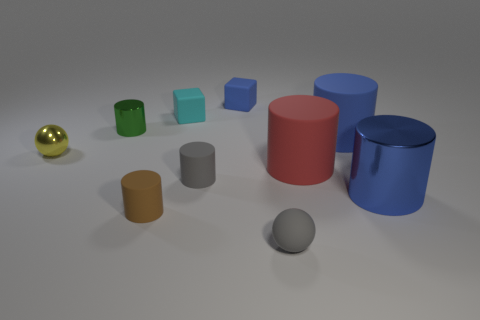Is the tiny yellow thing made of the same material as the big object that is in front of the big red cylinder?
Give a very brief answer. Yes. There is a blue cylinder behind the yellow thing; what is it made of?
Ensure brevity in your answer.  Rubber. What is the size of the yellow ball?
Provide a succinct answer. Small. There is a blue rubber object that is in front of the blue matte cube; is its size the same as the cube that is in front of the blue rubber cube?
Your answer should be compact. No. There is a blue metallic object that is the same shape as the large blue rubber object; what is its size?
Offer a very short reply. Large. There is a green thing; does it have the same size as the metallic cylinder in front of the green cylinder?
Provide a succinct answer. No. There is a block that is on the right side of the tiny cyan rubber cube; is there a blue cylinder on the right side of it?
Give a very brief answer. Yes. What is the shape of the small gray thing that is in front of the brown cylinder?
Your answer should be very brief. Sphere. There is a small cylinder that is the same color as the small rubber ball; what is its material?
Provide a succinct answer. Rubber. What color is the metal cylinder that is behind the metallic ball behind the brown matte cylinder?
Give a very brief answer. Green. 